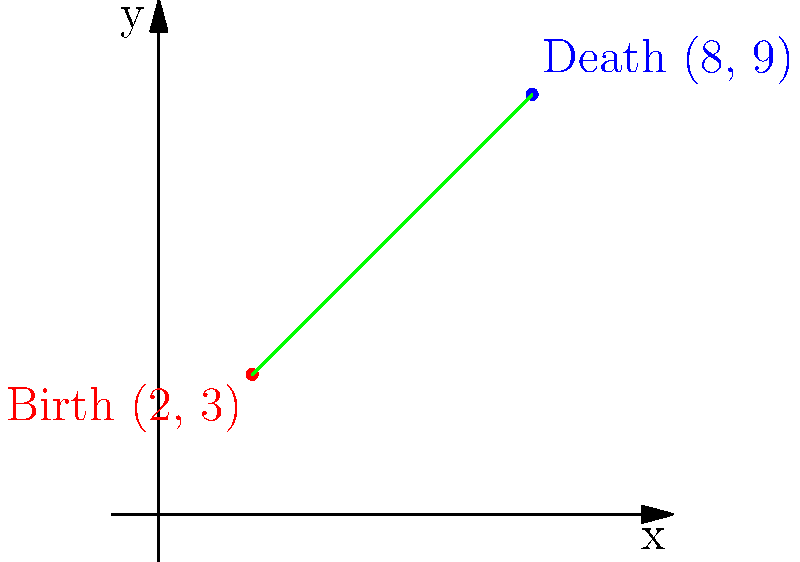Consider the birth and death locations of St. Augustine, a prominent religious figure and philosopher. His birthplace is represented by the point (2, 3), and his place of death is represented by (8, 9) on a coordinate plane. Calculate the slope of the line connecting these two significant locations in Augustine's life. To find the slope of the line connecting St. Augustine's birth and death locations, we'll use the slope formula:

$$ m = \frac{y_2 - y_1}{x_2 - x_1} $$

Where $(x_1, y_1)$ is the birth location and $(x_2, y_2)$ is the death location.

Step 1: Identify the coordinates
Birth location (x₁, y₁) = (2, 3)
Death location (x₂, y₂) = (8, 9)

Step 2: Substitute the values into the slope formula
$$ m = \frac{9 - 3}{8 - 2} $$

Step 3: Simplify the numerator and denominator
$$ m = \frac{6}{6} $$

Step 4: Perform the division
$$ m = 1 $$

Therefore, the slope of the line connecting St. Augustine's birth and death locations is 1.
Answer: 1 